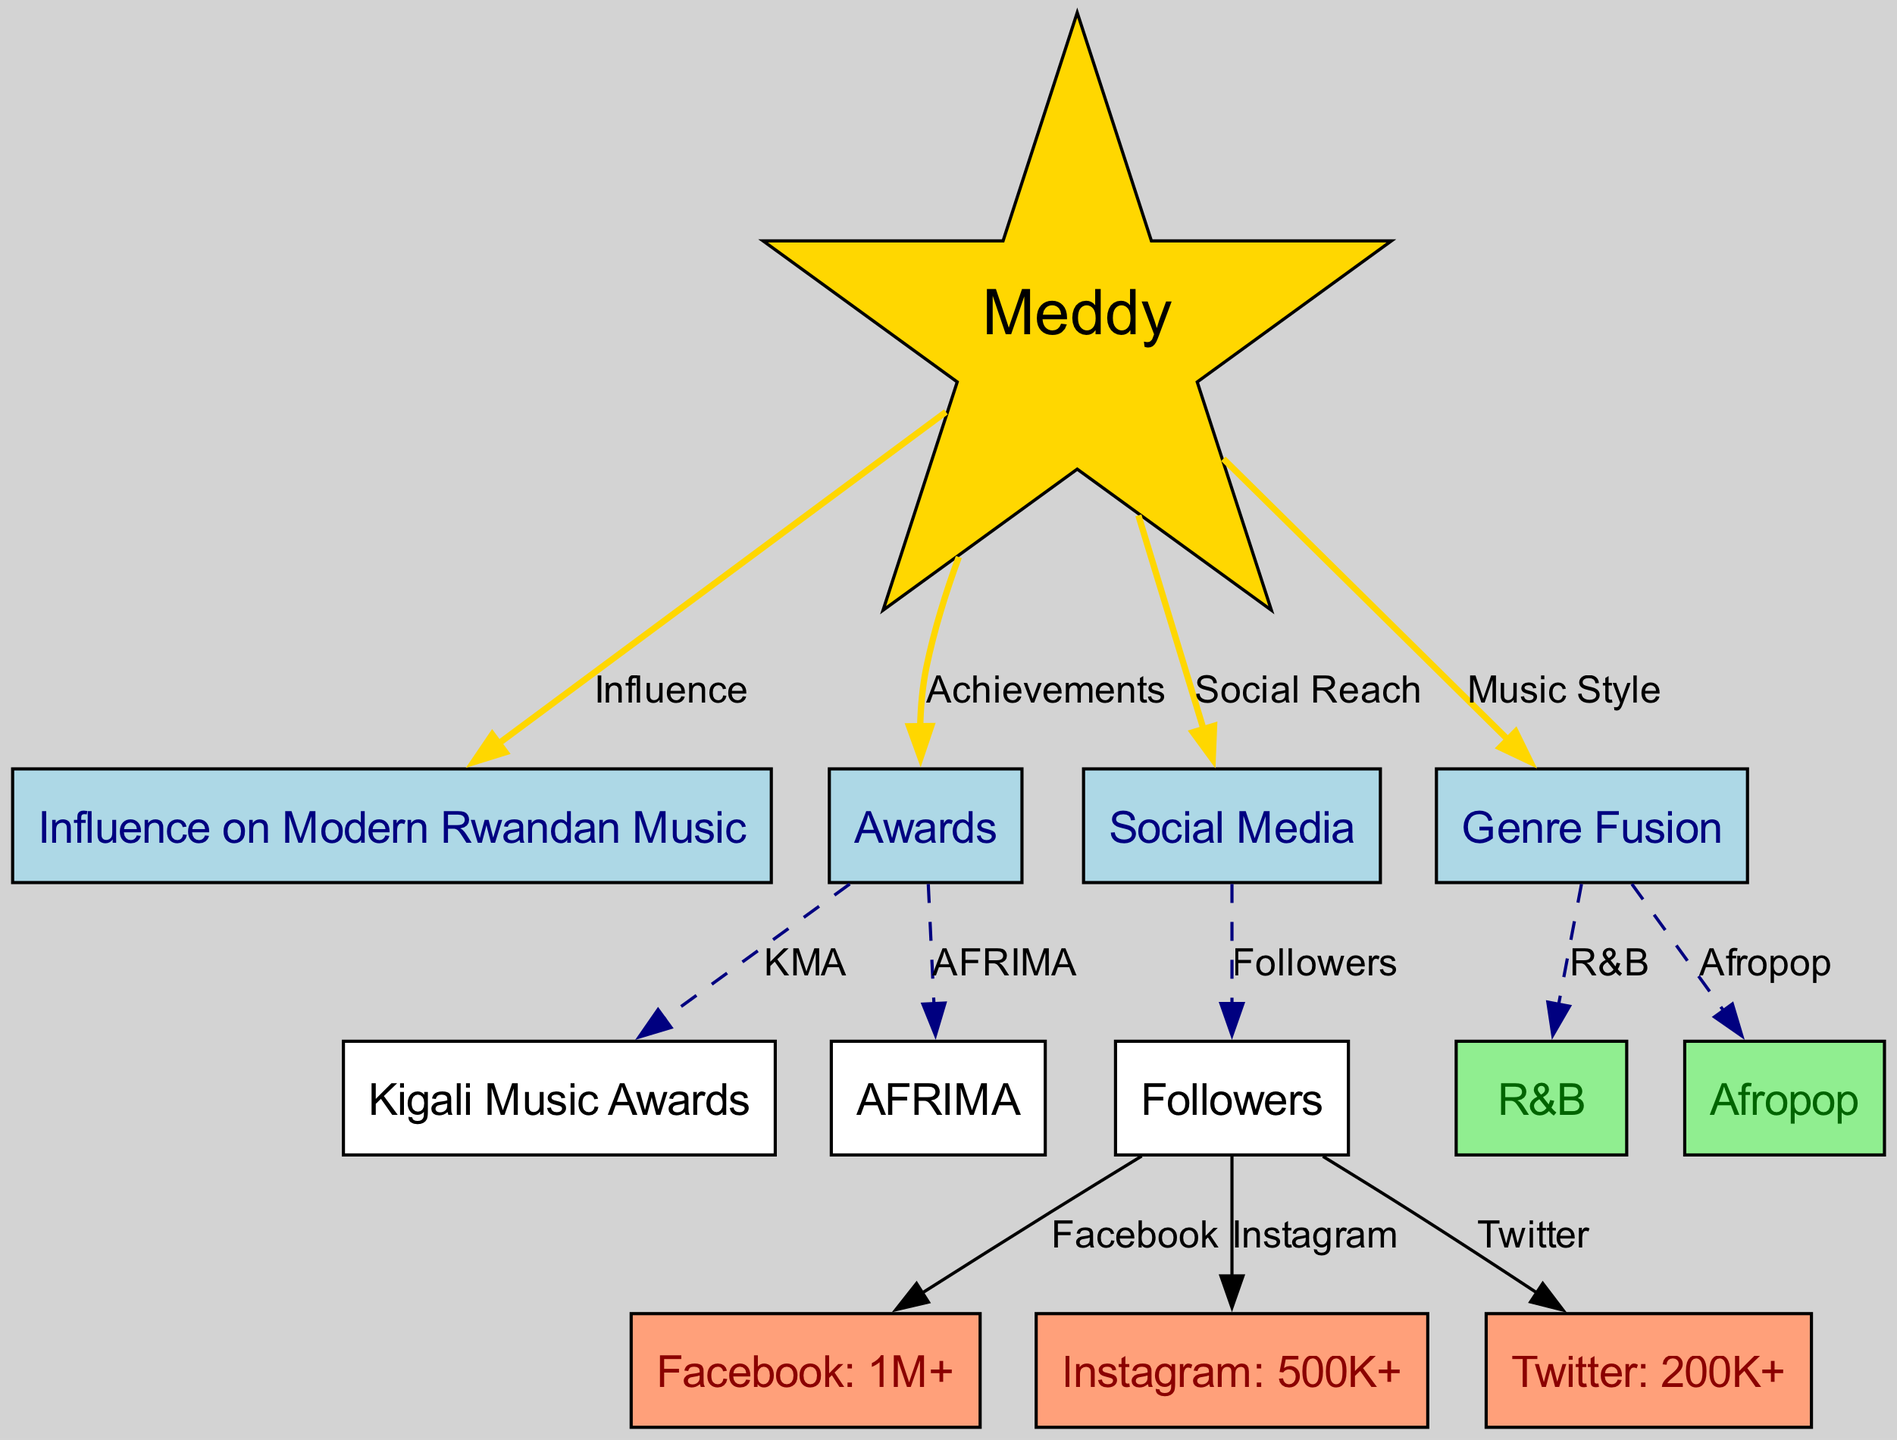What is the total number of nodes in the diagram? The diagram includes all the entities represented by circles (nodes). Counting each unique label (Meddy, Influence on Modern Rwandan Music, Awards, Social Media, Followers, Facebook, Instagram, Twitter, Genre Fusion, R&B, Afropop, Kigali Music Awards, AFRIMA), we find there are 12 distinct nodes.
Answer: 12 How many followers does Meddy have on Instagram? Referring to the node labeled "Instagram: 500K+", we see that it directly links to the "Followers" node. Thus, the specific figure mentioned in the diagram indicates that he has 500,000+ Instagram followers.
Answer: 500K+ Which award is represented by the node connected to 'Awards'? The "Kigali Music Awards" and "AFRIMA" nodes both connect to the "Awards" node, showing that these are the awards associated with Meddy. Since the question only requires one award, it can refer to either or both.
Answer: Kigali Music Awards or AFRIMA What is the total number of followers across all social media platforms mentioned? Meddy's total social media following is represented cumulatively by the followers on Facebook (1M+), Instagram (500K+), and Twitter (200K+). Adding these, we can interpret the total as "1M+ + 500K+ + 200K+" which yields a significant online presence.
Answer: 1.7M+ (1 Million + 500 Thousand + 200 Thousand) Which music genres have been fused according to the diagram? The "Genre Fusion" node branches out to two specific genres: "R&B" and "Afropop." This indicates that Meddy's music style incorporates both of these genres.
Answer: R&B and Afropop What type of relationship is shown between Meddy and his influence on modern Rwandan music? The diagram uses a direct edge titled "Influence" connecting Meddy to the "Influence on Modern Rwandan Music" node, indicating a strong direct influence is attributed to him in this specific context.
Answer: Influence How many social media platforms are represented in the diagram? The "Followers" node provides three branches labeled "Facebook," "Instagram," and "Twitter." This indicates that Meddy is active on these three distinct social media platforms.
Answer: 3 What is the significance of the node labeled 'meddy' in the diagram? This node titled "Meddy" serves as the central subject of the entire diagram. It connects to various aspects such as influence, awards, social media metrics, and musical styles, indicating that Meddy’s career encompasses multiple important areas in modern Rwandan music.
Answer: Central Subject 